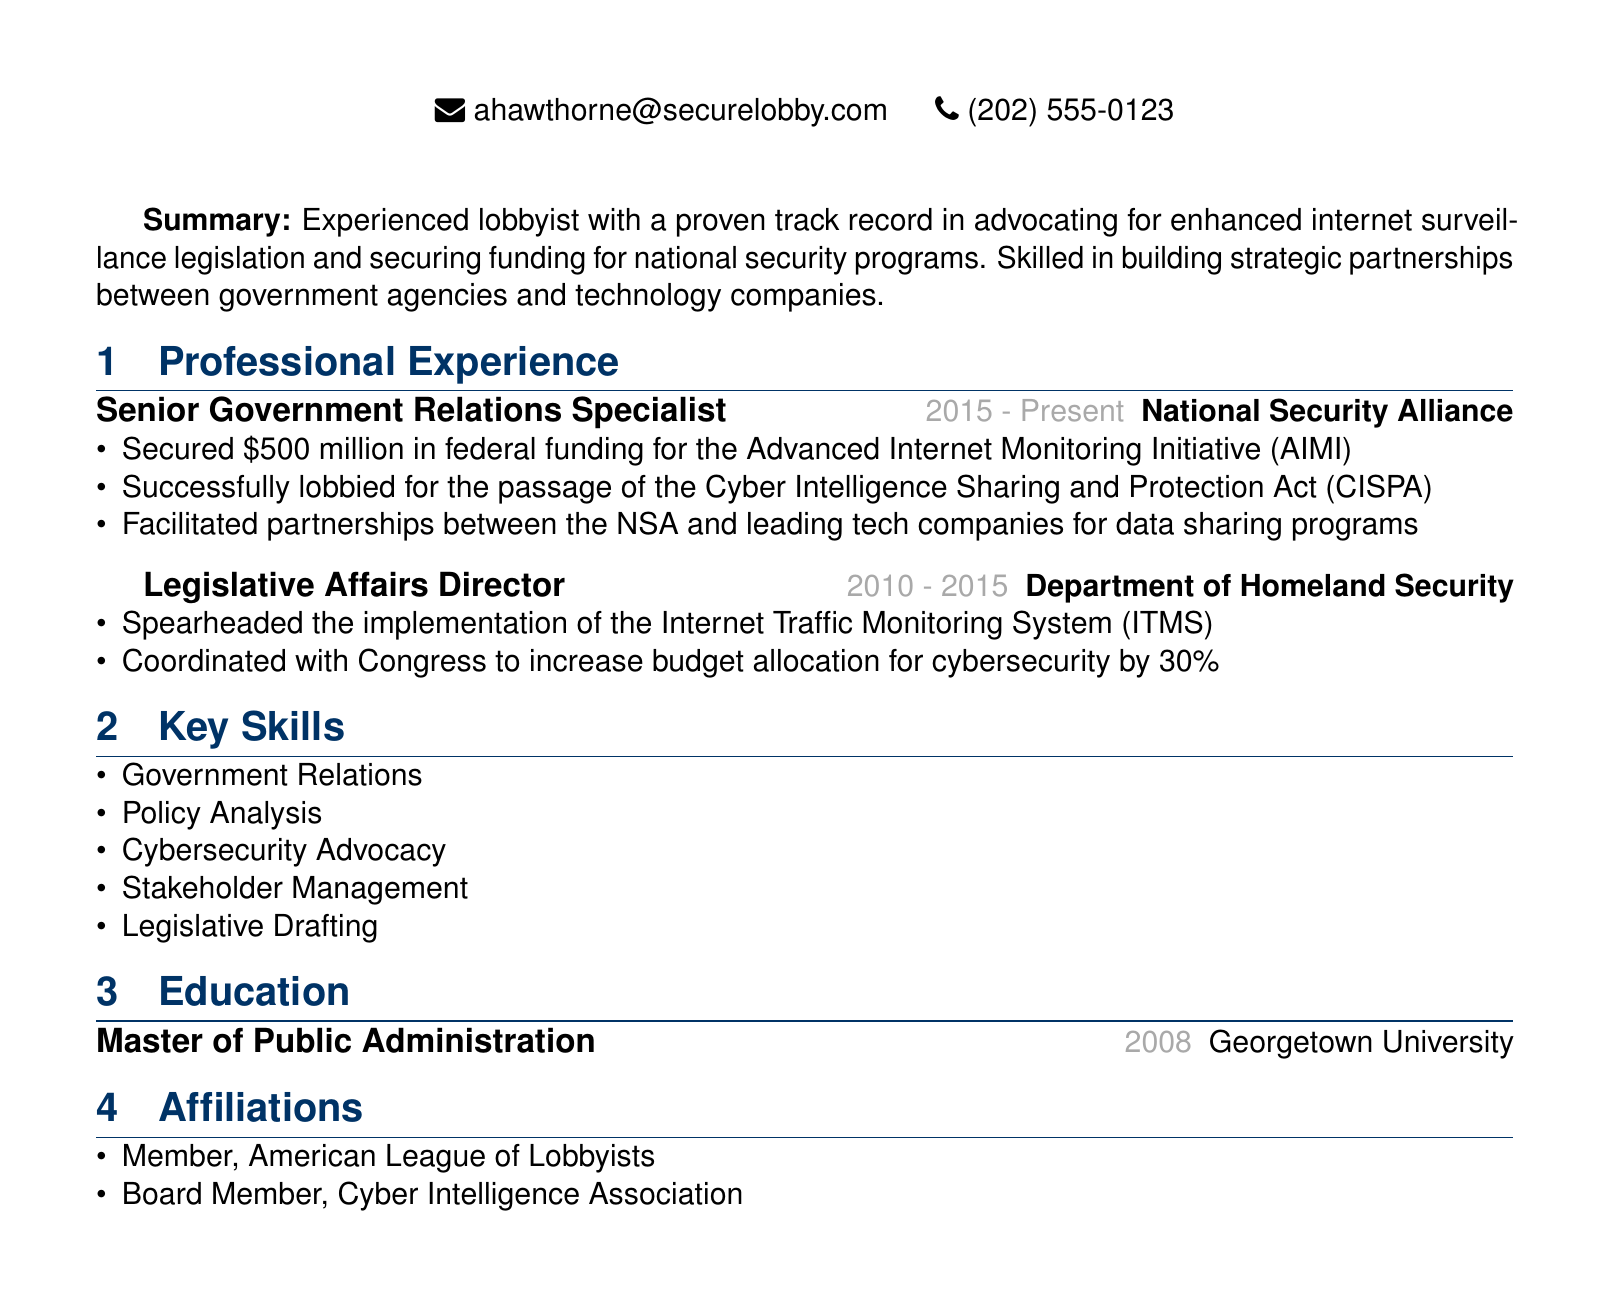What is Alexandra Hawthorne's current title? Her current title is listed in the document under her name at the top, which states she is a Senior Government Relations Specialist.
Answer: Senior Government Relations Specialist In which year did Alexandra complete her Master's degree? The education section states she earned her Master's degree in 2008.
Answer: 2008 How much federal funding did Alexandra secure for the Advanced Internet Monitoring Initiative? The achievement under her current position specifies that she secured $500 million in federal funding for this initiative.
Answer: $500 million What legislation did Alexandra lobby for the passage of? The document mentions she successfully lobbied for the passage of the Cyber Intelligence Sharing and Protection Act (CISPA).
Answer: Cyber Intelligence Sharing and Protection Act (CISPA) What was the percentage increase in budget allocation for cybersecurity that Alexandra coordinated with Congress? The achievements listed under her previous position specify a 30% increase in the budget allocation for cybersecurity.
Answer: 30% Which organization did Alexandra work for from 2010 to 2015? The document states that she held the position of Legislative Affairs Director at the Department of Homeland Security during that time period.
Answer: Department of Homeland Security What key skill related to her profession is listed in her resume? The key skills section includes several skills, one of which is Cybersecurity Advocacy, indicating her focus in this area.
Answer: Cybersecurity Advocacy What is one of Alexandra's current affiliations? The affiliations section lists that she is a member of the American League of Lobbyists.
Answer: American League of Lobbyists 